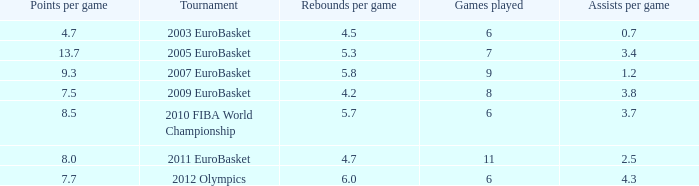How many games played have 4.7 points per game? 1.0. 